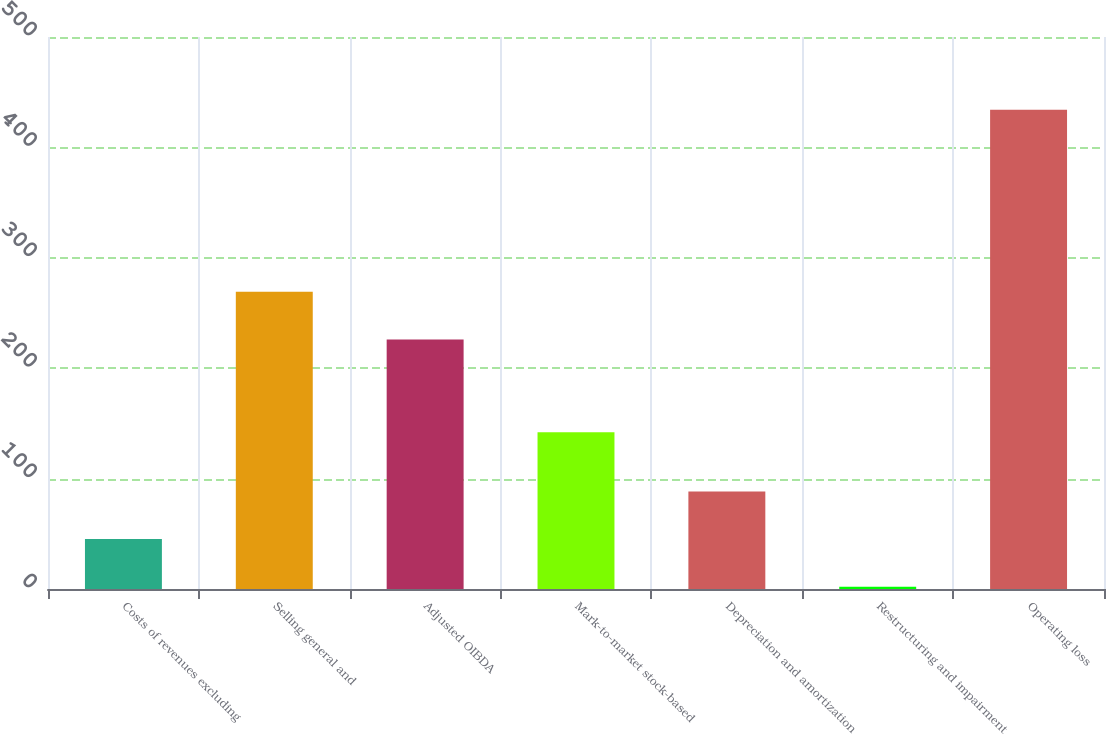<chart> <loc_0><loc_0><loc_500><loc_500><bar_chart><fcel>Costs of revenues excluding<fcel>Selling general and<fcel>Adjusted OIBDA<fcel>Mark-to-market stock-based<fcel>Depreciation and amortization<fcel>Restructuring and impairment<fcel>Operating loss<nl><fcel>45.2<fcel>269.2<fcel>226<fcel>142<fcel>88.4<fcel>2<fcel>434<nl></chart> 